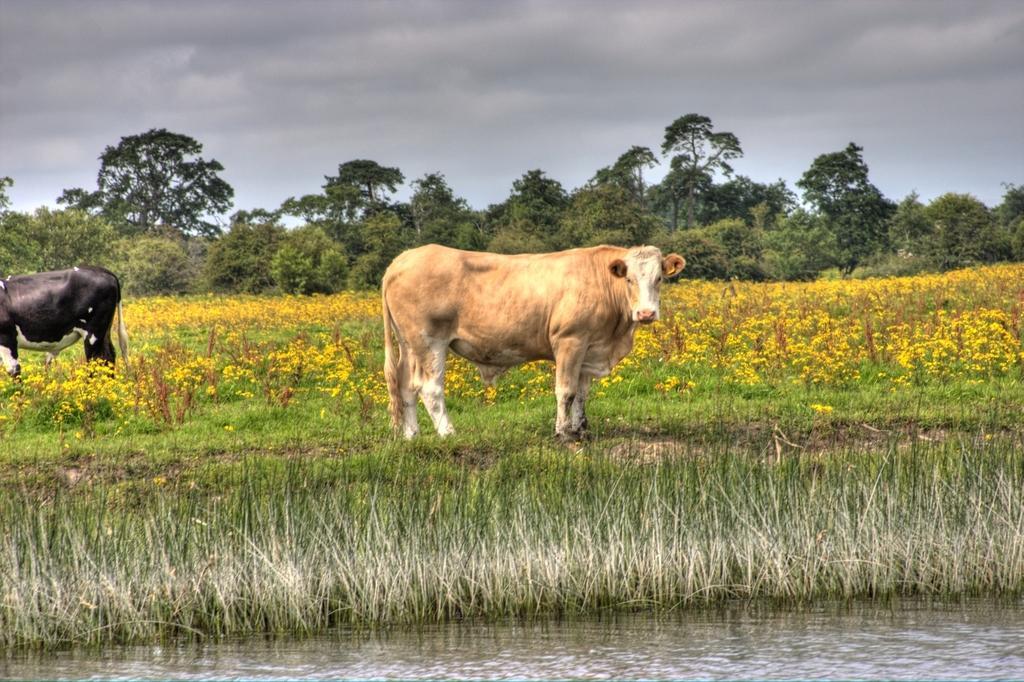Could you give a brief overview of what you see in this image? This image is clicked outside. There are cows in the middle. There is water at the bottom. There is grass in the middle. There are flowers in the middle. There are trees in the middle. There is sky at the top. 